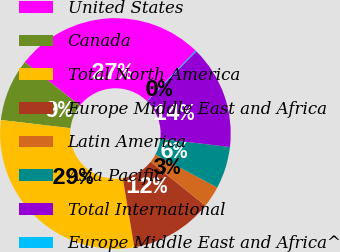Convert chart. <chart><loc_0><loc_0><loc_500><loc_500><pie_chart><fcel>United States<fcel>Canada<fcel>Total North America<fcel>Europe Middle East and Africa<fcel>Latin America<fcel>Asia Pacific<fcel>Total International<fcel>Europe Middle East and Africa^<nl><fcel>26.62%<fcel>8.75%<fcel>29.49%<fcel>11.62%<fcel>3.01%<fcel>5.88%<fcel>14.49%<fcel>0.14%<nl></chart> 